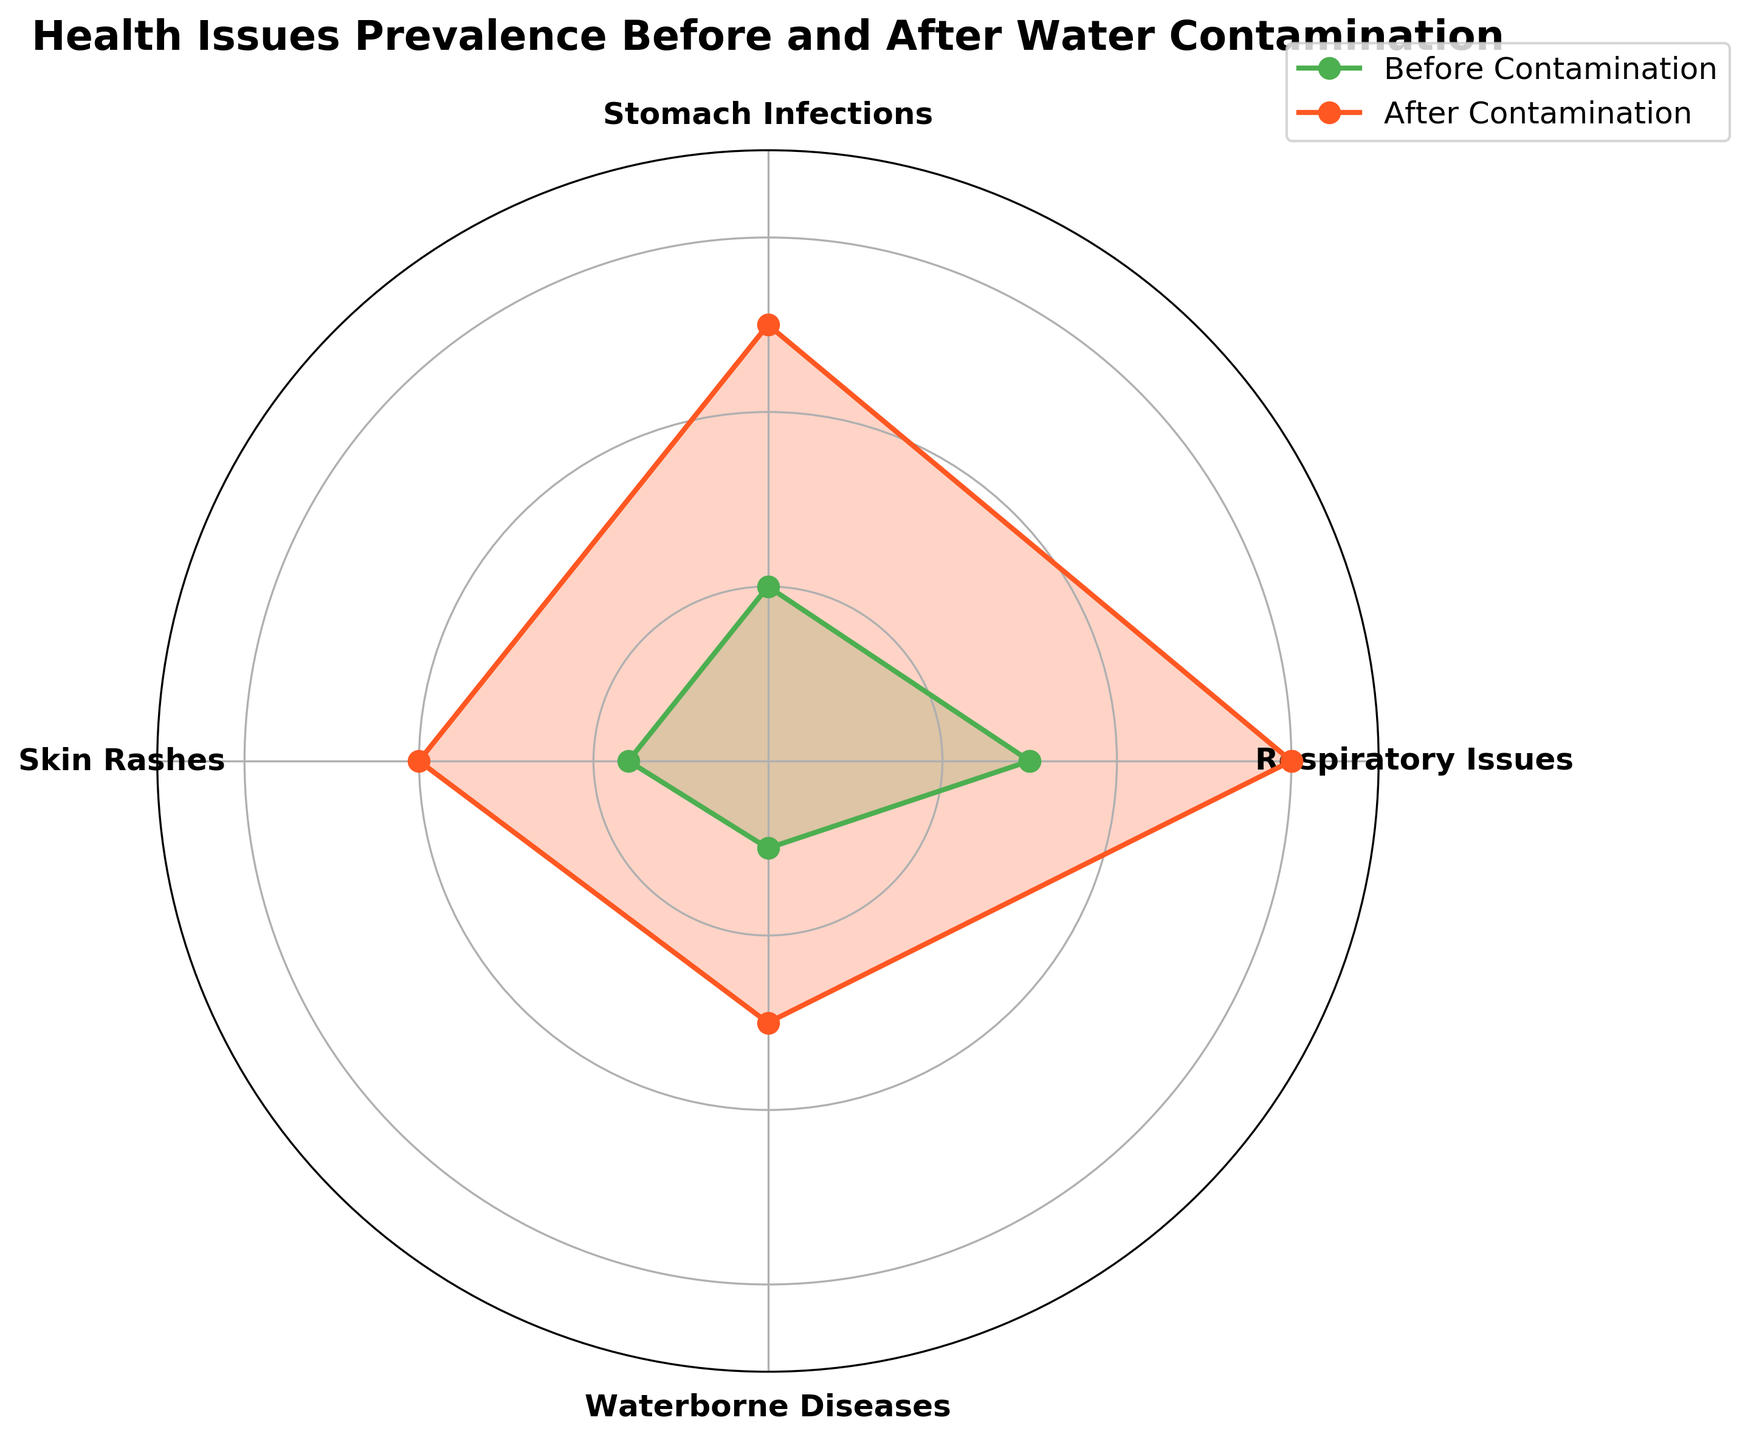What is the title of the figure? Look at the top of the figure where the title is usually placed. The title indicates the main subject of the chart.
Answer: Health Issues Prevalence Before and After Water Contamination How many health issues are represented in the radar chart? Count the categories around the radar chart as each category represents a different health issue.
Answer: 4 Which health issue had the highest increase in prevalence after contamination? Compare the prevalence before and after contamination for each health issue by visually inspecting the distances between the 'before' and 'after' lines.
Answer: Respiratory Issues What is the prevalence of skin rashes before contamination? Look at the point on the 'before contamination' line corresponding to 'Skin Rashes' and note the value on the radial grid.
Answer: 8 cases per 1000 By how much did the prevalence of waterborne diseases increase after contamination? Subtract the prevalence before contamination from the prevalence after contamination for 'Waterborne Diseases'. Calculation: 15 (after) - 5 (before).
Answer: 10 cases per 1000 Which health issue had the least prevalence before contamination? Compare the points on the 'before contamination' line for all health issues and find the lowest value.
Answer: Waterborne Diseases Did the prevalence of stomach infections double after contamination? Compare the prevalence of stomach infections before contamination to their prevalence after contamination by doubling the 'before' value and checking if it matches the 'after' value. Calculation: 10 * 2 = 20 (before), compare with 25 (after).
Answer: No On average, by how much did the prevalence of health issues increase after contamination? Calculate the increase for each health issue and then find the average. 
(30-15) + (25-10) + (20-8) + (15-5) = 15 + 15 + 12 + 10 => Total Increase = 52 
Number of Issues = 4 
Average Increase = 52/4
Answer: 13 cases per 1000 Which health issue had a prevalence of around 20 cases per 1000 after contamination? Look at the points on the 'after contamination' line and identify the health issue near the value of 20 on the radial grid.
Answer: Skin Rashes 